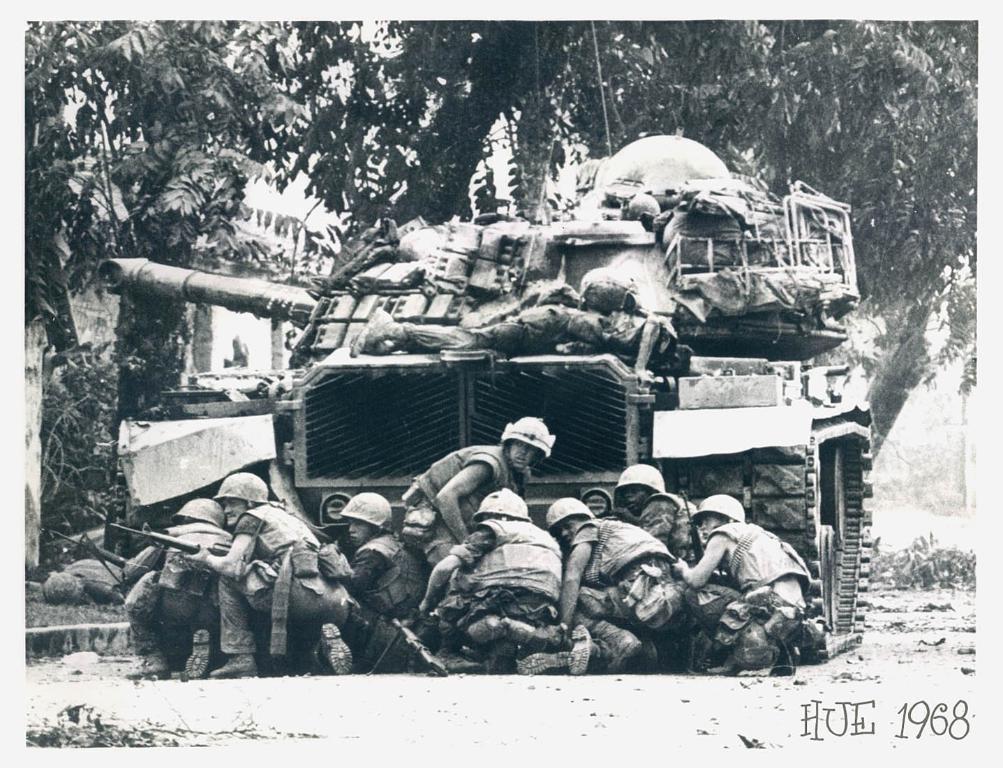Can you describe this image briefly? In this image there are many people kneeling on the ground. They are wearing jackets and helmets. They seem to be soldiers. Behind them there is a Churchill tank. There is a man lying on the Churchill tank. In the background there are trees. In the bottom right there is text on the image. 